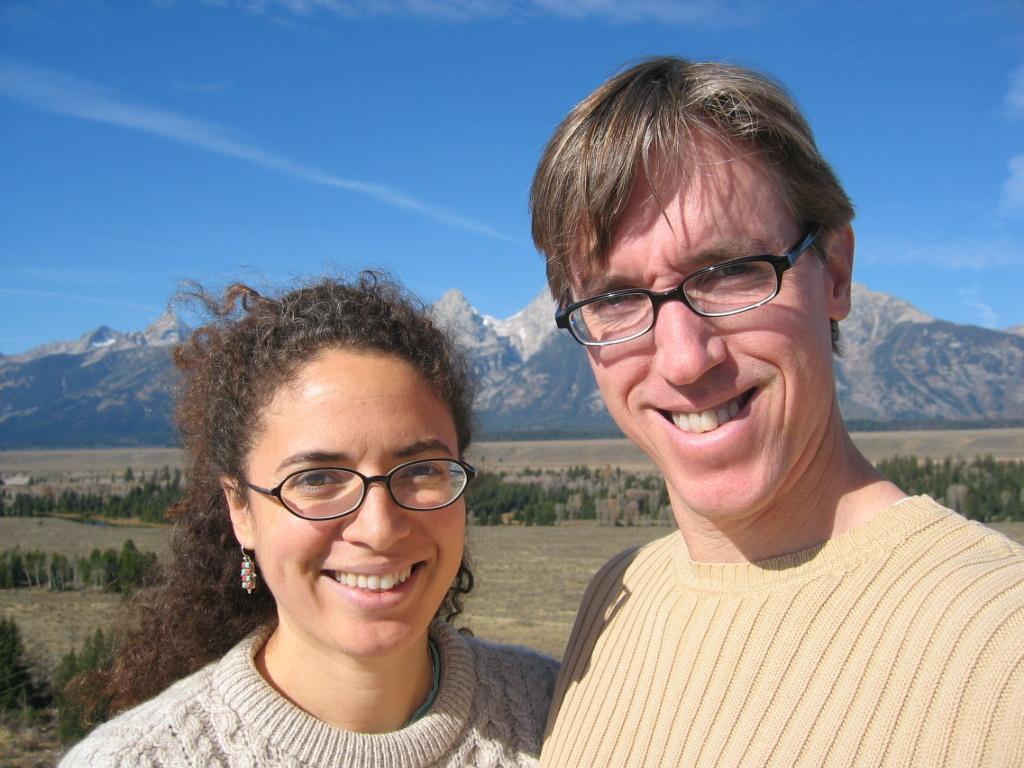Describe this image in one or two sentences. In this image in the front there are persons smiling. In the background there are plants and mountains and at the top we can see clouds in the sky. 